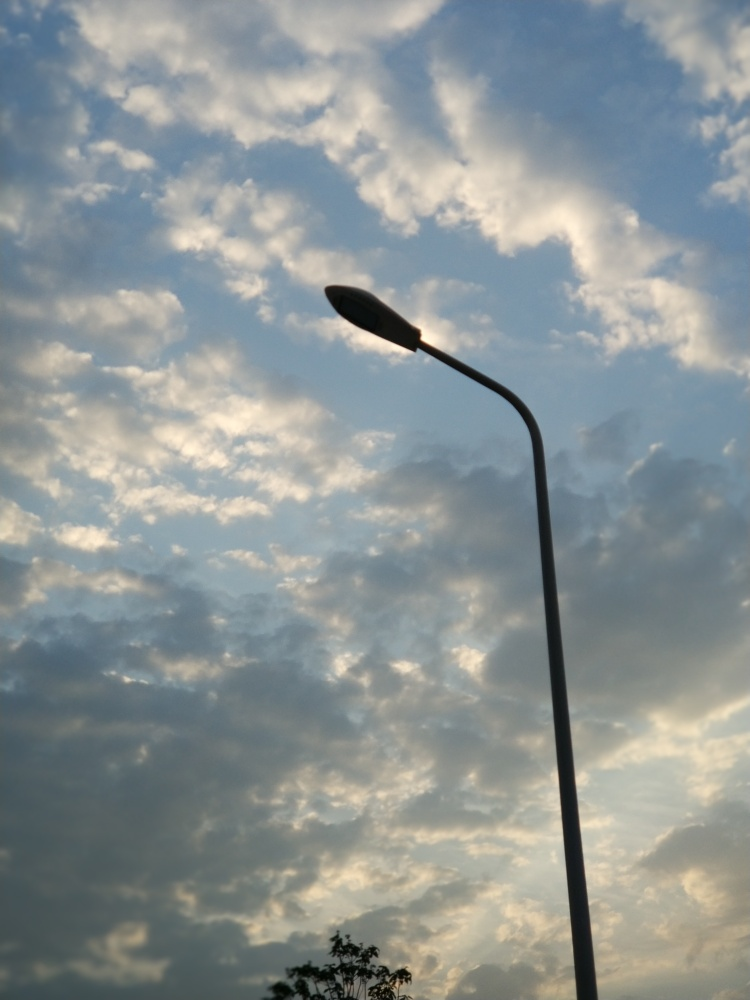How is the focus in this image?
A. unfocused
B. blurred
C. accurate The focus in the image is accurate, with the street lamp in the foreground sharply outlined against the soft backdrop of a sky filled with clouds. Each cloud puff is distinct, and the overall composition delivers a sense of depth that is clear and well-defined. 